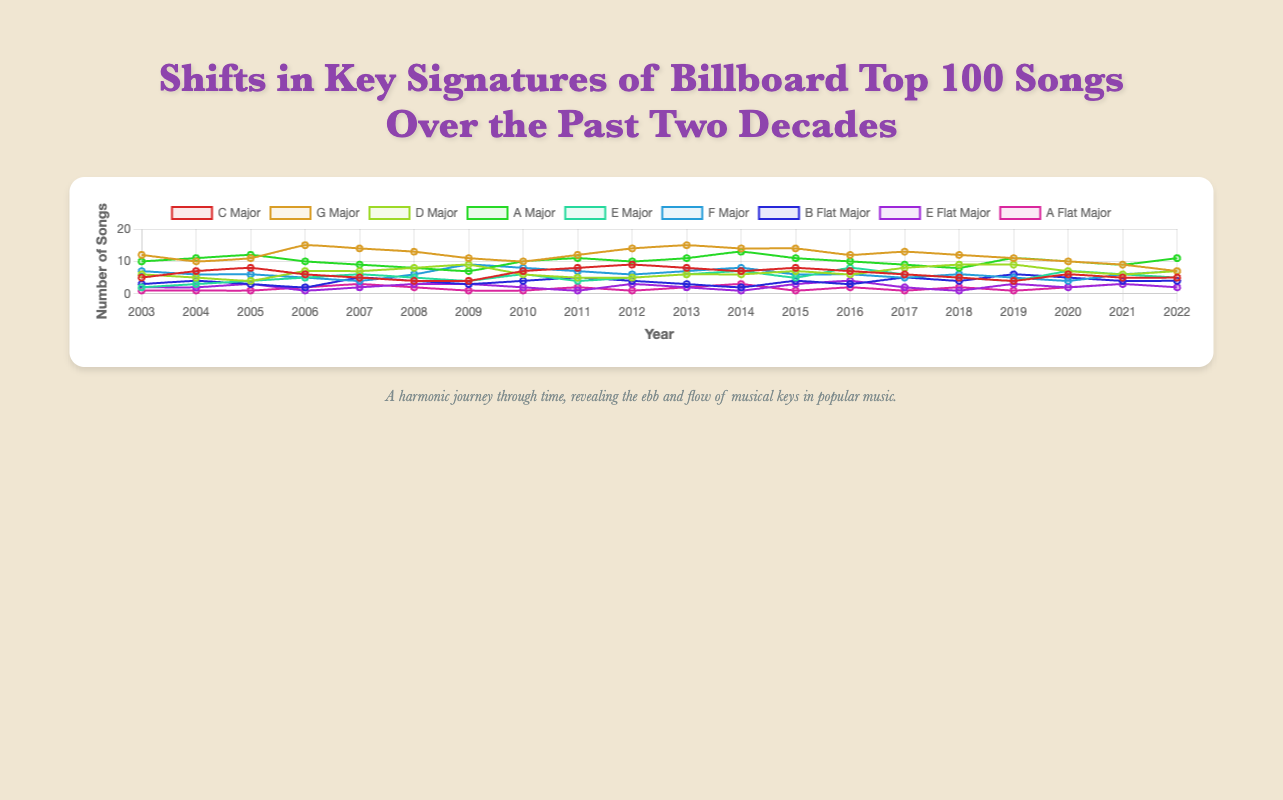Which key signature had the highest number of songs in 2012? To determine the key signature with the highest number of songs in 2012, look at the y-axis values for 2012 for each key signature. The highest value corresponds to G Major with a count of 14 songs.
Answer: G Major From 2006 to 2008, how did the number of songs in E Major change? Look at the data points for E Major in 2006, 2007, and 2008: they are 5, 6, and 5 respectively. The number of songs increased from 5 to 6 from 2006 to 2007, then decreased back to 5 from 2007 to 2008.
Answer: Increased, then decreased Which key signature showed a consistent decrease from 2010 to 2022? Check each key signature's values from 2010 to 2022. G Major showed a consistent decrease over this period, dropping from 10 songs in 2010 to 7 songs in 2022.
Answer: G Major Compare the number of songs in A Major and B Flat Major in 2015. Which one had more, and by how much? In 2015, A Major had 11 songs and B Flat Major had 4 songs. The difference is 11 - 4 = 7.
Answer: A Major by 7 What is the average number of songs in C Major over the two decades? Sum the counts for C Major from 2003 to 2022: 5+7+8+6+5+4+4+7+8+9+8+7+8+7+6+5+4+6+5+5 = 120. Divide by 20 years: 120 / 20 = 6.
Answer: 6 Between A Major and D Major, which one had the highest peak value and what was it? Look for the highest single value for A Major and D Major from 2003 to 2022. A Major's peak value is 13 in 2014, whereas D Major's peak is 9, occurring in multiple years.
Answer: A Major with 13 How did the number of songs in F Major change between 2008 and 2010? In 2008, F Major had 6 songs; in 2009, it increased to 9; and in 2010, it decreased to 8. The change from 2008 to 2010 is 6 -> 9 -> 8.
Answer: Increased, then decreased What was the total number of songs in minor key signatures (E Flat Major and A Flat Major) in 2020? Add the counts for E Flat Major and A Flat Major in 2020: 2 (E Flat Major) + 2 (A Flat Major) = 4.
Answer: 4 Which year had the highest variety of key signatures represented, and how many were there? Check the number of unique key signatures with non-zero counts for each year. The year with the highest number of unique key signatures represented was 2010, with all 9 key signatures showing up.
Answer: 2010 with 9 Describe the trend for B Flat Major from 2003 to 2022. Examining the values for B Flat Major from 2003 to 2022, it started at 3, had some fluctuations, and generally ended at 4 in 2022 without a clear increasing or decreasing trend.
Answer: Fluctuating, no clear trend 